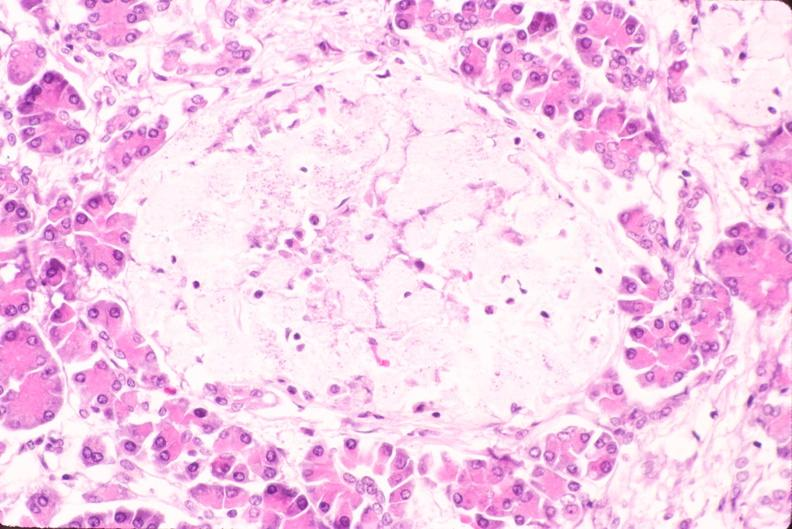what does this image show?
Answer the question using a single word or phrase. Pancreas 